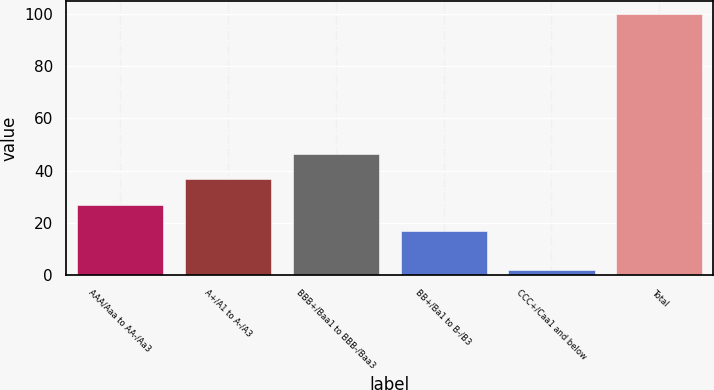<chart> <loc_0><loc_0><loc_500><loc_500><bar_chart><fcel>AAA/Aaa to AA-/Aa3<fcel>A+/A1 to A-/A3<fcel>BBB+/Baa1 to BBB-/Baa3<fcel>BB+/Ba1 to B-/B3<fcel>CCC+/Caa1 and below<fcel>Total<nl><fcel>26.8<fcel>36.6<fcel>46.4<fcel>17<fcel>2<fcel>100<nl></chart> 